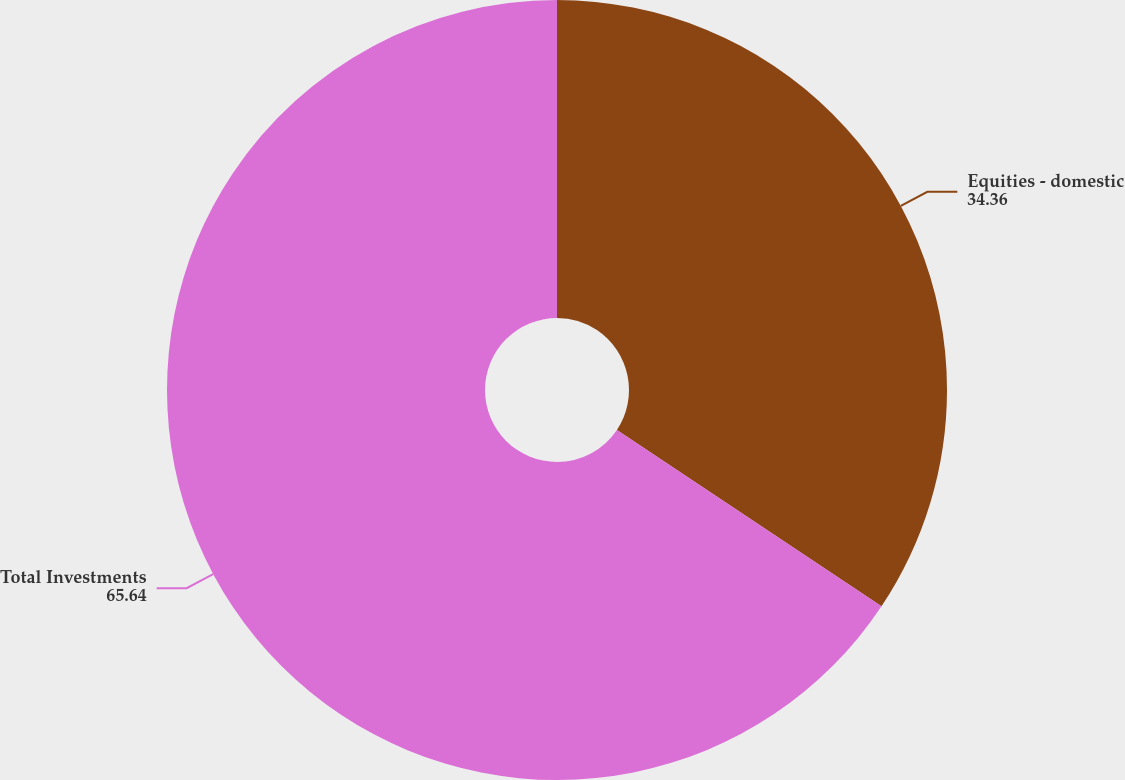<chart> <loc_0><loc_0><loc_500><loc_500><pie_chart><fcel>Equities - domestic<fcel>Total Investments<nl><fcel>34.36%<fcel>65.64%<nl></chart> 